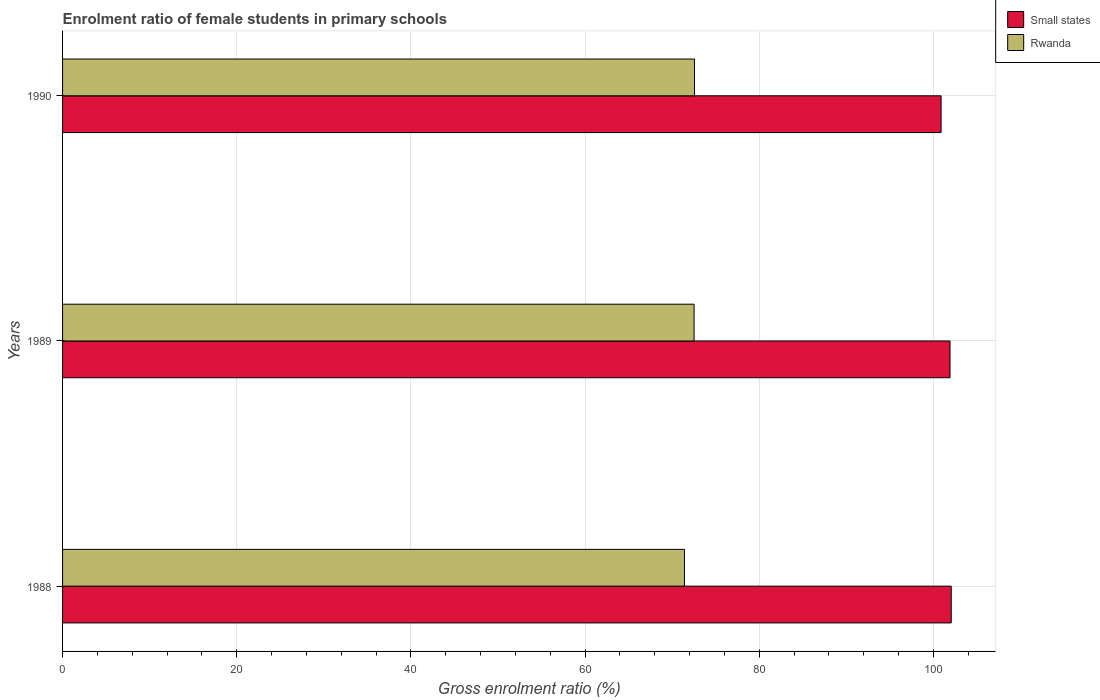Are the number of bars per tick equal to the number of legend labels?
Offer a terse response. Yes. How many bars are there on the 2nd tick from the top?
Offer a very short reply. 2. What is the label of the 1st group of bars from the top?
Make the answer very short. 1990. What is the enrolment ratio of female students in primary schools in Rwanda in 1990?
Your answer should be very brief. 72.57. Across all years, what is the maximum enrolment ratio of female students in primary schools in Rwanda?
Provide a succinct answer. 72.57. Across all years, what is the minimum enrolment ratio of female students in primary schools in Rwanda?
Provide a succinct answer. 71.42. In which year was the enrolment ratio of female students in primary schools in Rwanda minimum?
Ensure brevity in your answer.  1988. What is the total enrolment ratio of female students in primary schools in Rwanda in the graph?
Provide a short and direct response. 216.51. What is the difference between the enrolment ratio of female students in primary schools in Small states in 1989 and that in 1990?
Keep it short and to the point. 1.02. What is the difference between the enrolment ratio of female students in primary schools in Rwanda in 1990 and the enrolment ratio of female students in primary schools in Small states in 1988?
Provide a succinct answer. -29.48. What is the average enrolment ratio of female students in primary schools in Small states per year?
Provide a short and direct response. 101.62. In the year 1989, what is the difference between the enrolment ratio of female students in primary schools in Small states and enrolment ratio of female students in primary schools in Rwanda?
Provide a short and direct response. 29.39. What is the ratio of the enrolment ratio of female students in primary schools in Rwanda in 1988 to that in 1990?
Offer a very short reply. 0.98. Is the enrolment ratio of female students in primary schools in Small states in 1988 less than that in 1989?
Keep it short and to the point. No. Is the difference between the enrolment ratio of female students in primary schools in Small states in 1988 and 1989 greater than the difference between the enrolment ratio of female students in primary schools in Rwanda in 1988 and 1989?
Your answer should be compact. Yes. What is the difference between the highest and the second highest enrolment ratio of female students in primary schools in Rwanda?
Provide a short and direct response. 0.05. What is the difference between the highest and the lowest enrolment ratio of female students in primary schools in Small states?
Provide a succinct answer. 1.16. In how many years, is the enrolment ratio of female students in primary schools in Rwanda greater than the average enrolment ratio of female students in primary schools in Rwanda taken over all years?
Ensure brevity in your answer.  2. What does the 2nd bar from the top in 1990 represents?
Keep it short and to the point. Small states. What does the 2nd bar from the bottom in 1990 represents?
Ensure brevity in your answer.  Rwanda. Are all the bars in the graph horizontal?
Provide a short and direct response. Yes. Are the values on the major ticks of X-axis written in scientific E-notation?
Your answer should be very brief. No. Does the graph contain any zero values?
Keep it short and to the point. No. Where does the legend appear in the graph?
Your answer should be very brief. Top right. How many legend labels are there?
Provide a succinct answer. 2. How are the legend labels stacked?
Keep it short and to the point. Vertical. What is the title of the graph?
Your answer should be very brief. Enrolment ratio of female students in primary schools. What is the label or title of the X-axis?
Offer a terse response. Gross enrolment ratio (%). What is the label or title of the Y-axis?
Provide a short and direct response. Years. What is the Gross enrolment ratio (%) of Small states in 1988?
Ensure brevity in your answer.  102.05. What is the Gross enrolment ratio (%) of Rwanda in 1988?
Ensure brevity in your answer.  71.42. What is the Gross enrolment ratio (%) of Small states in 1989?
Offer a terse response. 101.91. What is the Gross enrolment ratio (%) in Rwanda in 1989?
Offer a very short reply. 72.52. What is the Gross enrolment ratio (%) of Small states in 1990?
Your response must be concise. 100.89. What is the Gross enrolment ratio (%) of Rwanda in 1990?
Your answer should be very brief. 72.57. Across all years, what is the maximum Gross enrolment ratio (%) in Small states?
Offer a very short reply. 102.05. Across all years, what is the maximum Gross enrolment ratio (%) in Rwanda?
Your answer should be very brief. 72.57. Across all years, what is the minimum Gross enrolment ratio (%) in Small states?
Ensure brevity in your answer.  100.89. Across all years, what is the minimum Gross enrolment ratio (%) of Rwanda?
Your answer should be very brief. 71.42. What is the total Gross enrolment ratio (%) in Small states in the graph?
Keep it short and to the point. 304.85. What is the total Gross enrolment ratio (%) of Rwanda in the graph?
Your response must be concise. 216.51. What is the difference between the Gross enrolment ratio (%) in Small states in 1988 and that in 1989?
Provide a succinct answer. 0.14. What is the difference between the Gross enrolment ratio (%) in Rwanda in 1988 and that in 1989?
Keep it short and to the point. -1.1. What is the difference between the Gross enrolment ratio (%) of Small states in 1988 and that in 1990?
Your answer should be compact. 1.16. What is the difference between the Gross enrolment ratio (%) of Rwanda in 1988 and that in 1990?
Make the answer very short. -1.15. What is the difference between the Gross enrolment ratio (%) in Small states in 1989 and that in 1990?
Give a very brief answer. 1.02. What is the difference between the Gross enrolment ratio (%) in Rwanda in 1989 and that in 1990?
Give a very brief answer. -0.05. What is the difference between the Gross enrolment ratio (%) of Small states in 1988 and the Gross enrolment ratio (%) of Rwanda in 1989?
Offer a terse response. 29.53. What is the difference between the Gross enrolment ratio (%) of Small states in 1988 and the Gross enrolment ratio (%) of Rwanda in 1990?
Give a very brief answer. 29.48. What is the difference between the Gross enrolment ratio (%) in Small states in 1989 and the Gross enrolment ratio (%) in Rwanda in 1990?
Provide a succinct answer. 29.34. What is the average Gross enrolment ratio (%) in Small states per year?
Provide a short and direct response. 101.62. What is the average Gross enrolment ratio (%) of Rwanda per year?
Your response must be concise. 72.17. In the year 1988, what is the difference between the Gross enrolment ratio (%) of Small states and Gross enrolment ratio (%) of Rwanda?
Your response must be concise. 30.63. In the year 1989, what is the difference between the Gross enrolment ratio (%) of Small states and Gross enrolment ratio (%) of Rwanda?
Give a very brief answer. 29.39. In the year 1990, what is the difference between the Gross enrolment ratio (%) of Small states and Gross enrolment ratio (%) of Rwanda?
Give a very brief answer. 28.32. What is the ratio of the Gross enrolment ratio (%) of Small states in 1988 to that in 1990?
Ensure brevity in your answer.  1.01. What is the ratio of the Gross enrolment ratio (%) of Rwanda in 1988 to that in 1990?
Ensure brevity in your answer.  0.98. What is the ratio of the Gross enrolment ratio (%) of Small states in 1989 to that in 1990?
Provide a short and direct response. 1.01. What is the ratio of the Gross enrolment ratio (%) in Rwanda in 1989 to that in 1990?
Your answer should be very brief. 1. What is the difference between the highest and the second highest Gross enrolment ratio (%) in Small states?
Ensure brevity in your answer.  0.14. What is the difference between the highest and the second highest Gross enrolment ratio (%) in Rwanda?
Give a very brief answer. 0.05. What is the difference between the highest and the lowest Gross enrolment ratio (%) in Small states?
Ensure brevity in your answer.  1.16. What is the difference between the highest and the lowest Gross enrolment ratio (%) of Rwanda?
Provide a short and direct response. 1.15. 